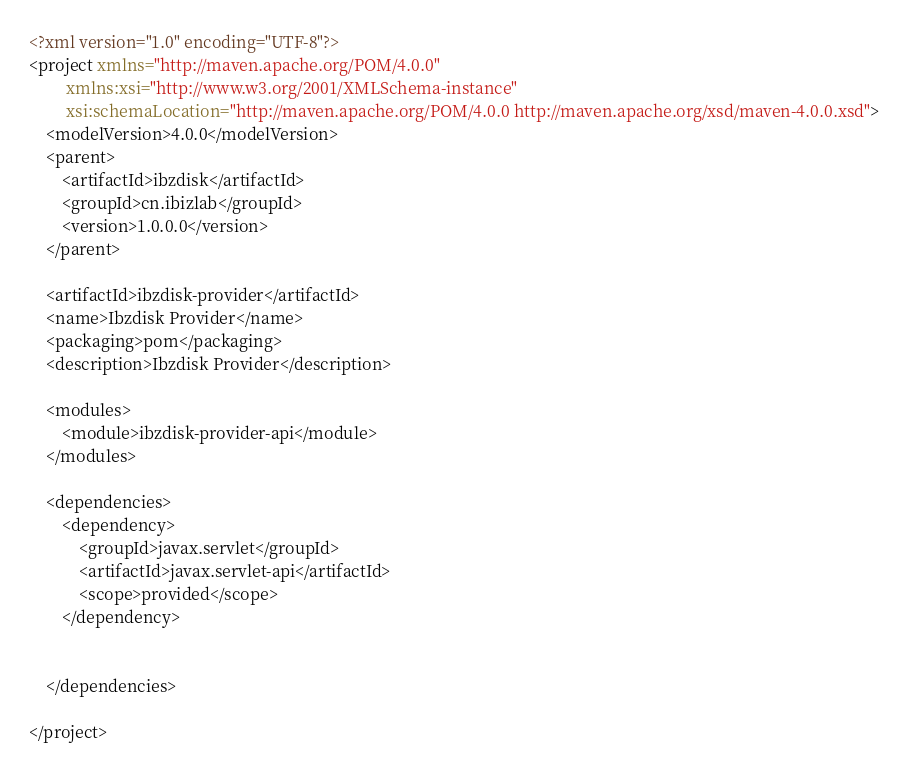Convert code to text. <code><loc_0><loc_0><loc_500><loc_500><_XML_><?xml version="1.0" encoding="UTF-8"?>
<project xmlns="http://maven.apache.org/POM/4.0.0"
         xmlns:xsi="http://www.w3.org/2001/XMLSchema-instance"
         xsi:schemaLocation="http://maven.apache.org/POM/4.0.0 http://maven.apache.org/xsd/maven-4.0.0.xsd">
    <modelVersion>4.0.0</modelVersion>
    <parent>
        <artifactId>ibzdisk</artifactId>
        <groupId>cn.ibizlab</groupId>
        <version>1.0.0.0</version>
    </parent>

    <artifactId>ibzdisk-provider</artifactId>
    <name>Ibzdisk Provider</name>
    <packaging>pom</packaging>
    <description>Ibzdisk Provider</description>

    <modules>
        <module>ibzdisk-provider-api</module>
    </modules>

    <dependencies>
		<dependency>
			<groupId>javax.servlet</groupId>
			<artifactId>javax.servlet-api</artifactId>
			<scope>provided</scope>
		</dependency>


	</dependencies>

</project>
</code> 